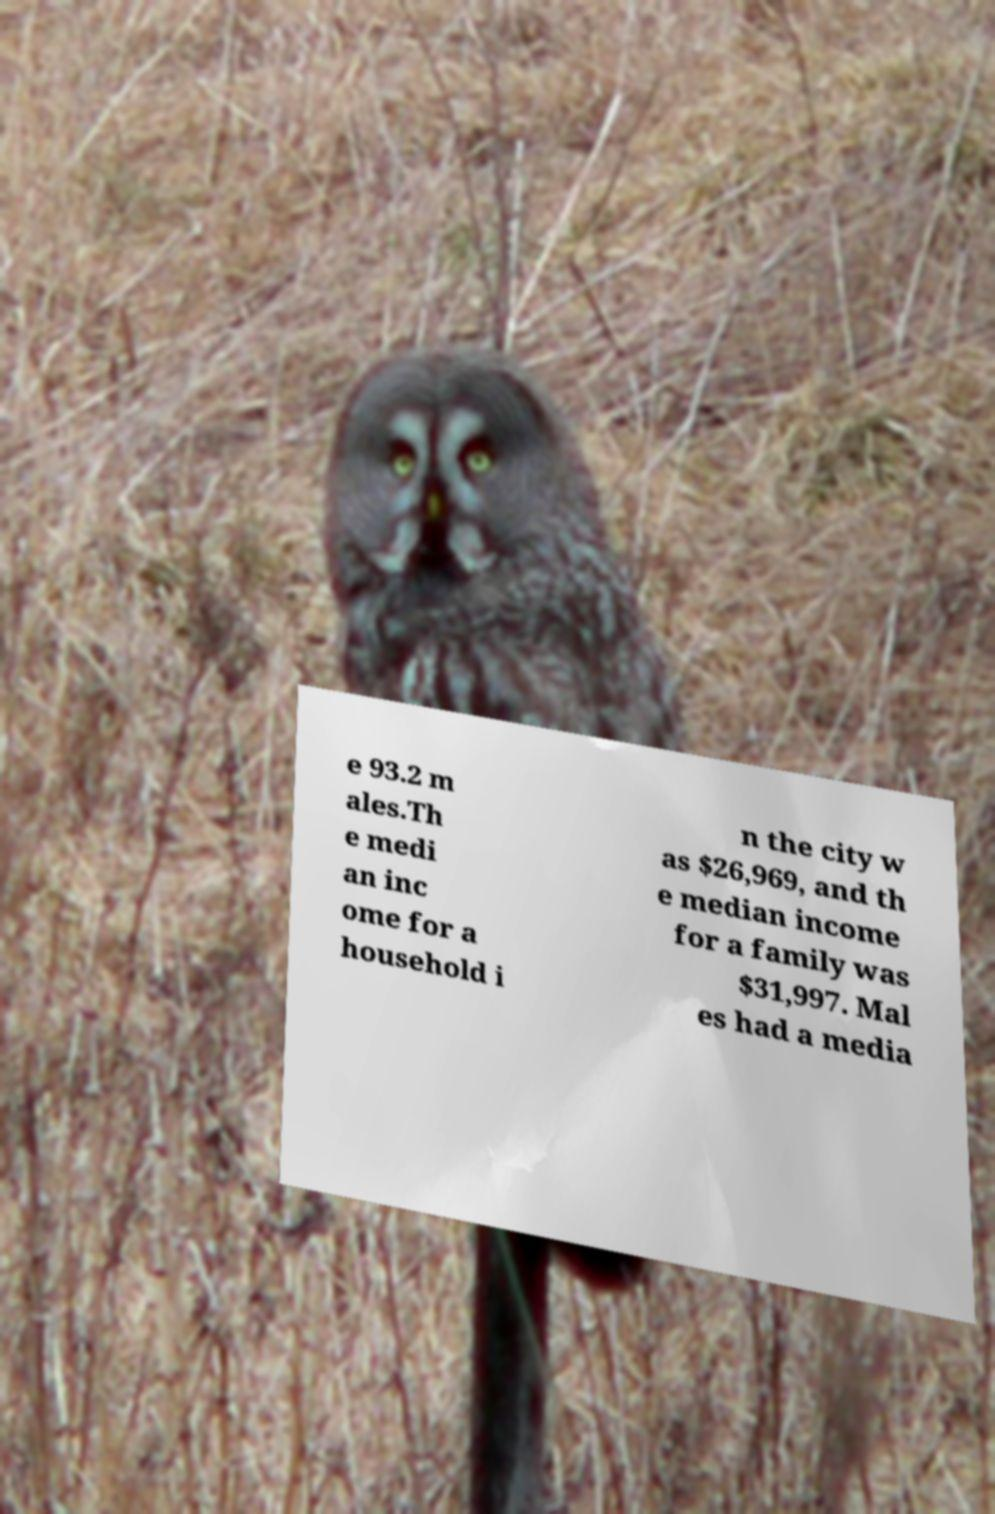Could you assist in decoding the text presented in this image and type it out clearly? e 93.2 m ales.Th e medi an inc ome for a household i n the city w as $26,969, and th e median income for a family was $31,997. Mal es had a media 